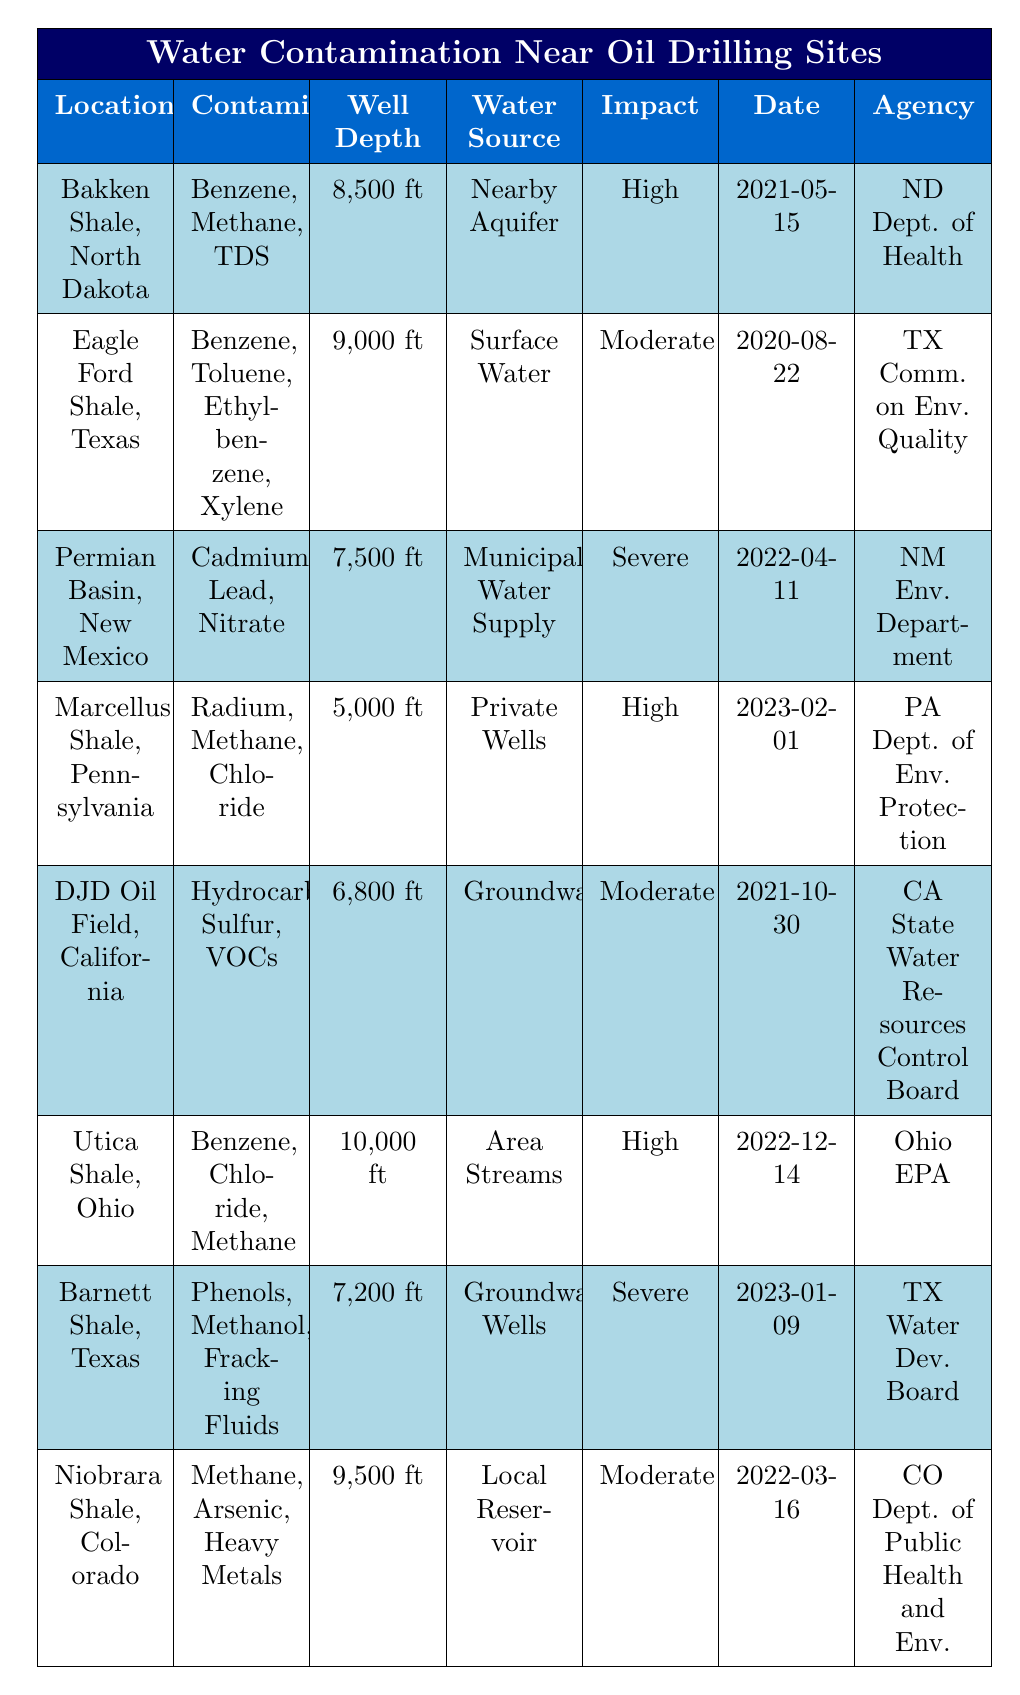What contaminants were found in the Permian Basin, New Mexico? The table specifies that the contaminants found in the Permian Basin, New Mexico, are Cadmium, Lead, and Nitrate.
Answer: Cadmium, Lead, Nitrate What is the impact level of water contamination in the Bakken Shale? Referring to the table, the impact level of water contamination in the Bakken Shale, North Dakota, is categorized as High.
Answer: High How many locations report severe impact levels? Looking at the table, the locations with severe impact levels are the Permian Basin, New Mexico, and Barnett Shale, Texas. This totals to two locations.
Answer: 2 Which sampling agency conducted the investigation in Ohio? According to the table, the agency that conducted the investigation in Ohio (Utica Shale) is the Ohio Environmental Protection Agency.
Answer: Ohio Environmental Protection Agency Which location has the deepest well and what is its depth? The Utica Shale in Ohio has the deepest well at a depth of 10,000 feet, as stated in the table.
Answer: 10,000 ft Was there any detection of Methane in the Marcellus Shale, Pennsylvania? The table indicates that Methane is indeed one of the contaminants found in the Marcellus Shale, Pennsylvania, making this statement true.
Answer: Yes What is the average well depth of the locations listed? The well depths listed are 8,500 ft, 9,000 ft, 7,500 ft, 5,000 ft, 6,800 ft, 10,000 ft, 7,200 ft, and 9,500 ft. To find the average: (8500 + 9000 + 7500 + 5000 + 6800 + 10000 + 7200 + 9500) = 60500 ft. There are 8 locations, thus the average is 60500 ft / 8 = 7562.5 ft.
Answer: 7562.5 ft Which location reports High impact level and uses private wells as a water source? The Marcellus Shale, Pennsylvania reports a High impact level and uses Private Wells as the water source, as indicated in the table.
Answer: Marcellus Shale, Pennsylvania Do any locations report 'Volatile Organic Compounds' as a contaminant? The DJD Oil Field in California is the only location that reports Volatile Organic Compounds (VOCs) as a contaminant according to the table.
Answer: Yes Which state has the highest number of contaminants recorded and what are they? The Barnett Shale in Texas has the highest number of contaminants listed at three, which are Phenols, Methanol, and Fracking Fluids, as per the table.
Answer: Barnett Shale, Texas; Phenols, Methanol, Fracking Fluids Is the impact level of water contamination in the Niobrara Shale Moderate or Severe? The table states that the impact level of water contamination in the Niobrara Shale, Colorado is categorized as Moderate, confirming that it is not Severe.
Answer: Moderate 